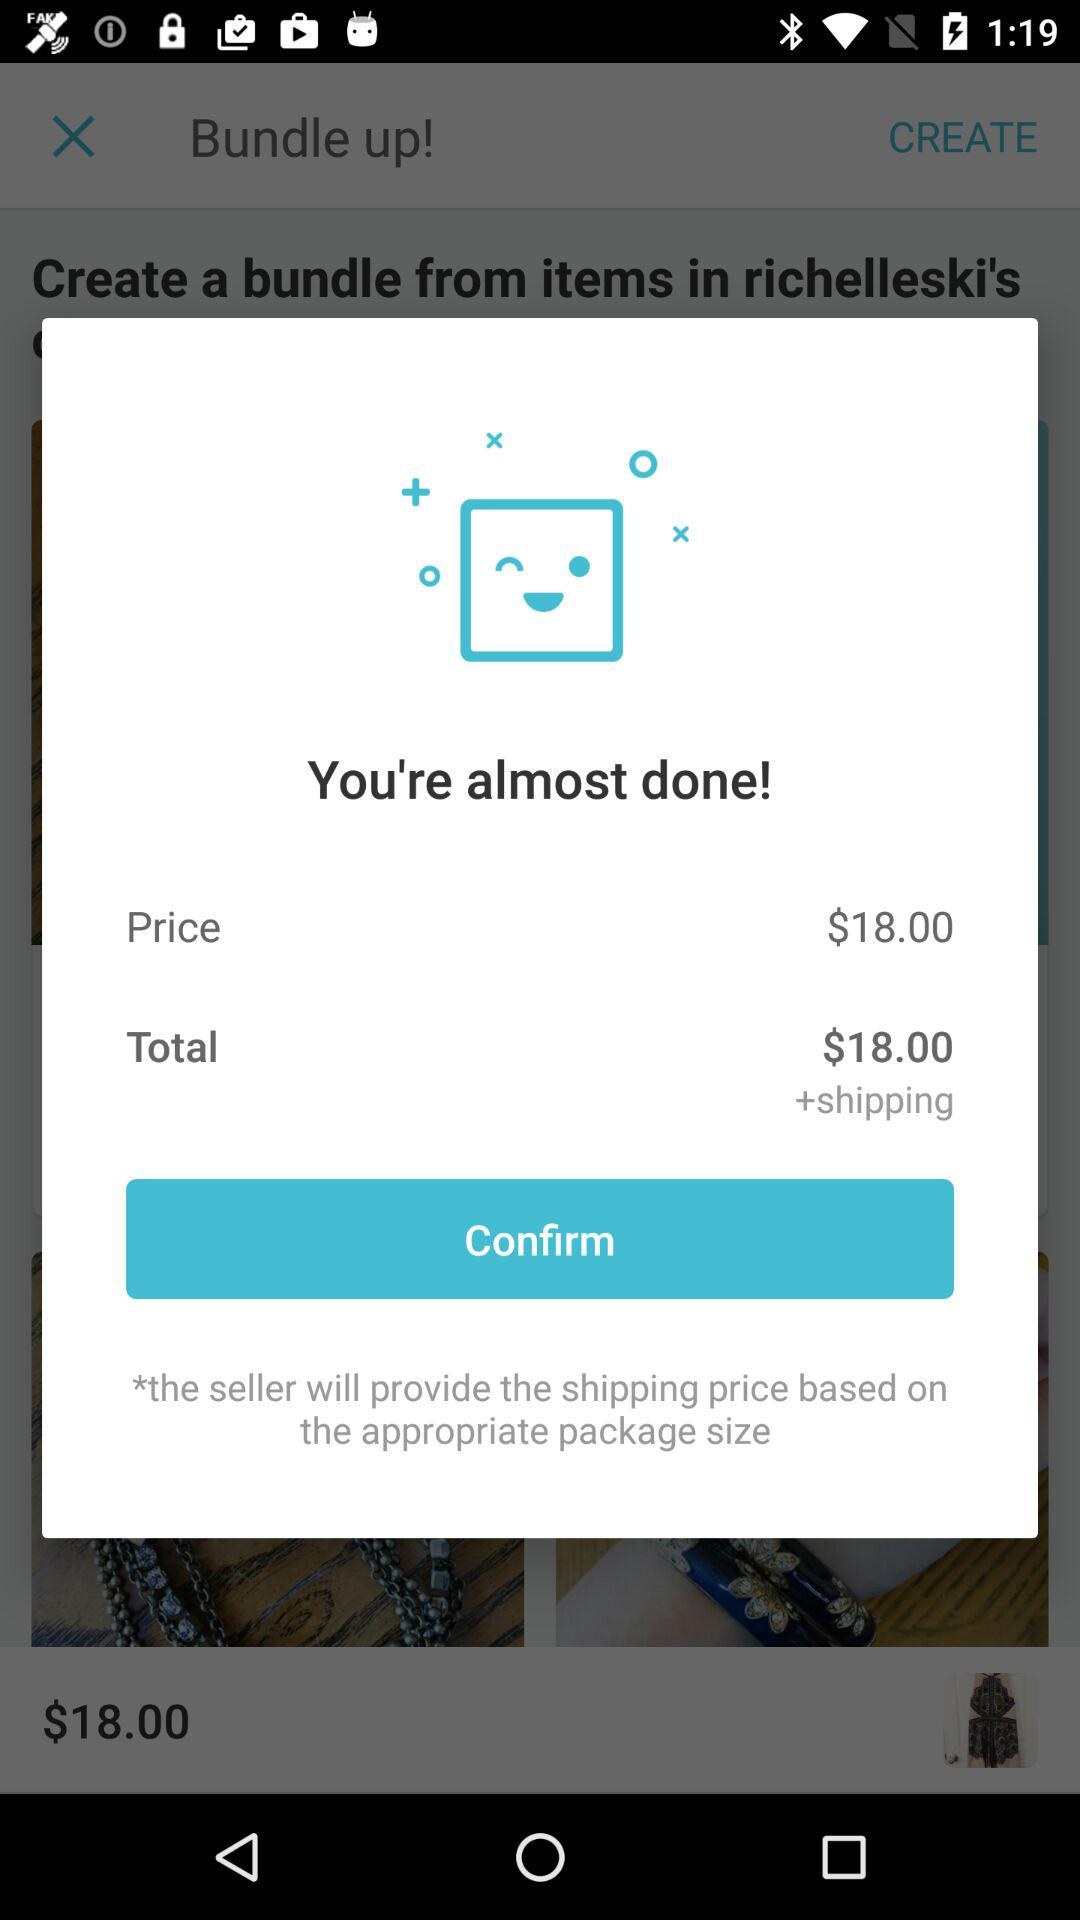How much is the total price?
Answer the question using a single word or phrase. $18.00 